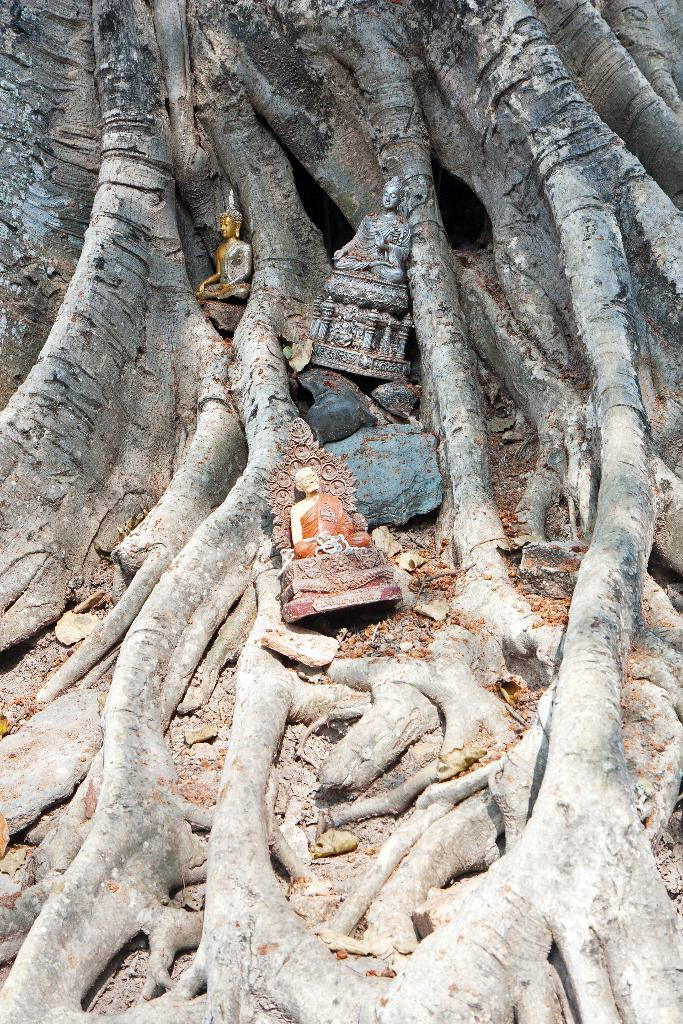What is placed on the roots of the tree in the image? There are person idols on the roots of the tree. Where is the tree located? The tree is on the land. What else can be seen on the land besides the tree? There are leaves and rocks on the land. What type of straw is being used to celebrate the birth of the person idols in the image? There is no straw or celebration of a birth present in the image; it features person idols on the roots of a tree and other elements on the land. What type of station is visible in the image? There is no station present in the image; it features person idols on the roots of a tree and other elements on the land. 